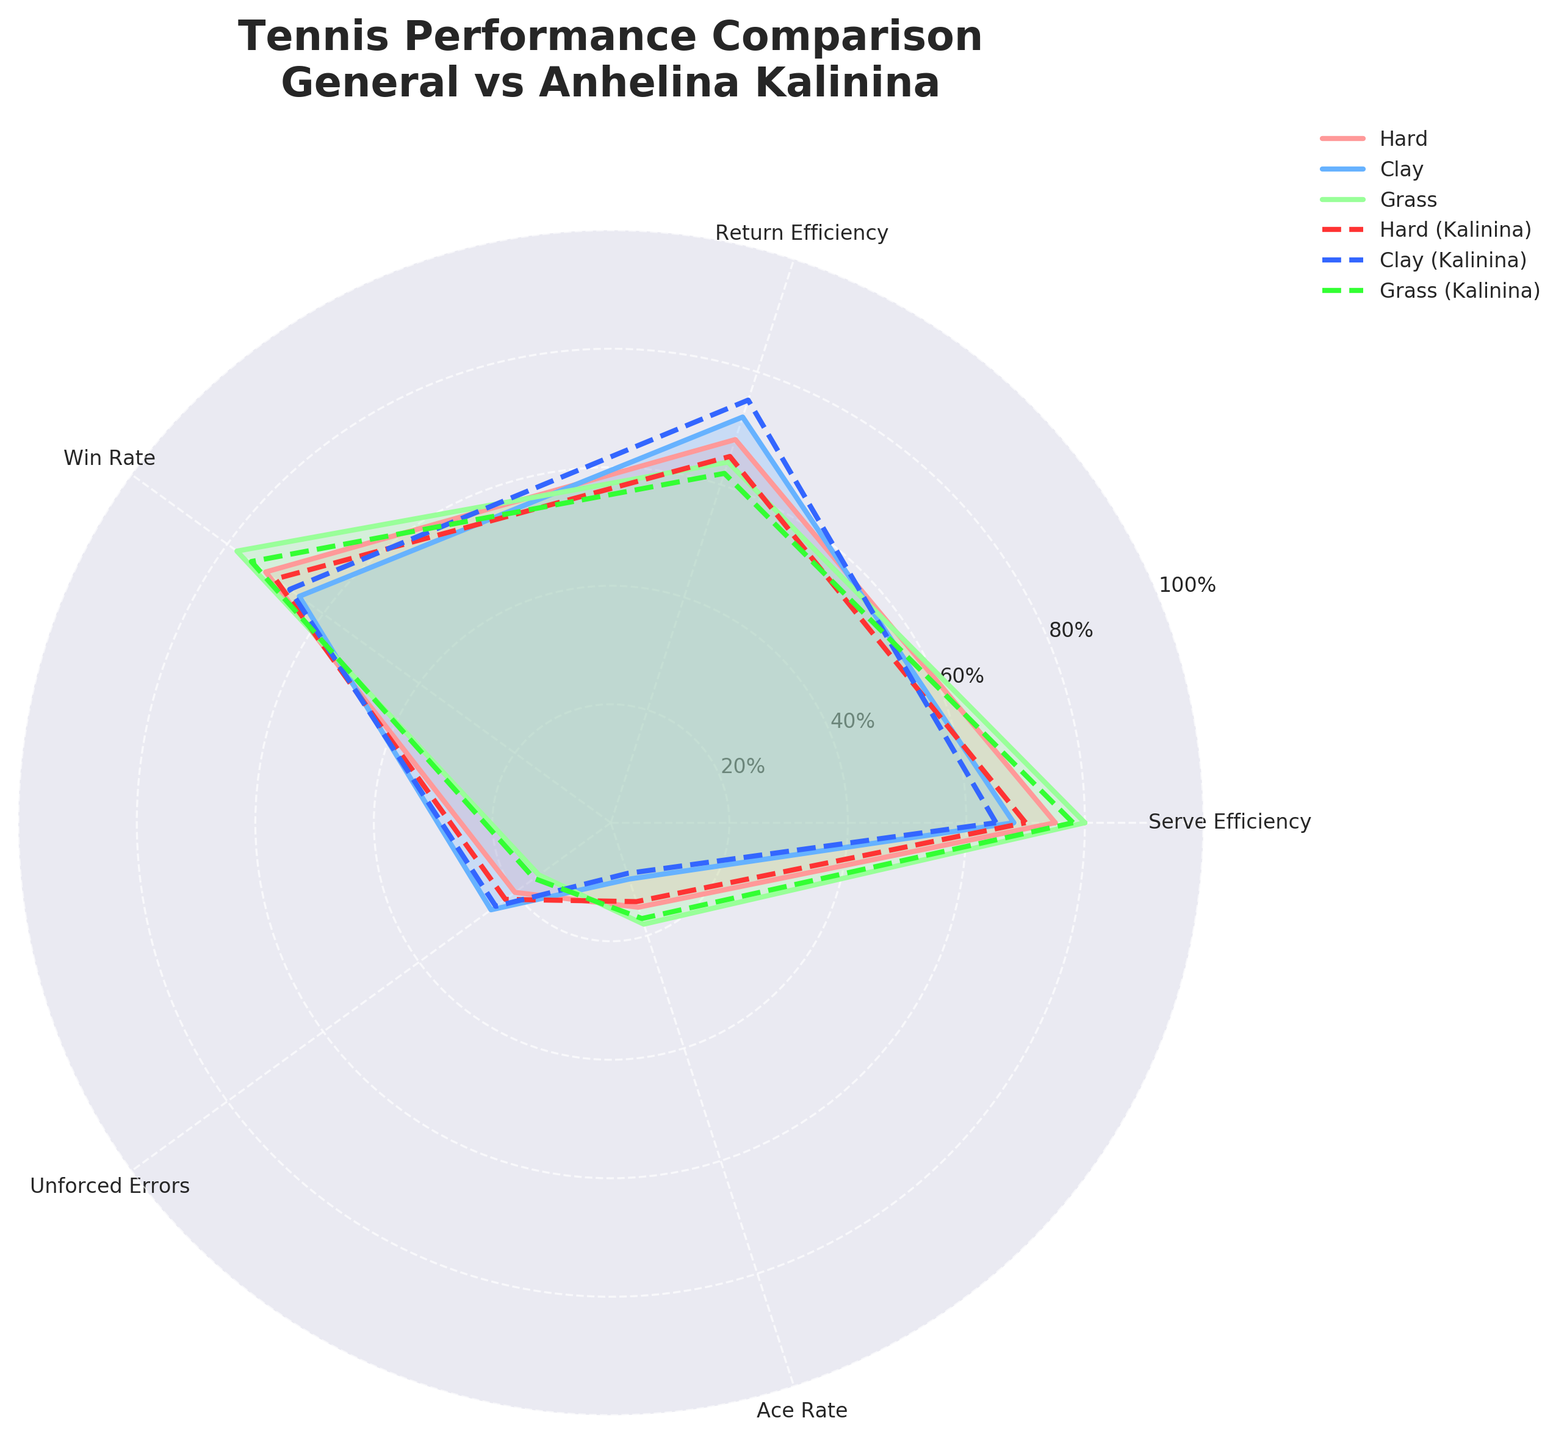What's the title of the figure? The title of the figure is indicated at the top and provides an overview of the data being presented.
Answer: Tennis Performance Comparison\nGeneral vs Anhelina Kalinina What surfaces are compared in the radar chart? The radar chart has separate lines representing different surfaces for both general players and Anhelina Kalinina.
Answer: Hard, Clay, Grass Which surface shows the highest Serve Efficiency for Anhelina Kalinina? By looking at the lines representing Anhelina Kalinina’s performance, we compare the Serve Efficiency values.
Answer: Grass How does Anhelina Kalinina's Ace Rate on Grass compare to the general player's Ace Rate on Grass? By observing the lines corresponding to Grass for both sets of data, we determine the Ace Rate for each.
Answer: Lower Which attribute has the largest difference in performance between general players and Anhelina Kalinina on Clay? We need to compare each attribute vertically between the general data and Anhelina Kalinina's data for Clay and find the one with the highest absolute difference.
Answer: Return Efficiency Between which surfaces does Anhelina Kalinina show the least variation in Win Rate? By comparing the Win Rate values of Anhelina Kalinina across all surfaces, we determine the surfaces with the closest values.
Answer: Hard and Clay What is the average Unforced Errors rate for Anhelina Kalinina across all surfaces? We sum the Unforced Errors rates for Anhelina Kalinina for each surface and divide by the number of surfaces (3).
Answer: (22 + 24 + 16) / 3 = 20.67 Which surface corresponds to the highest Win Rate for general players? By comparing the Win Rate values for each surface for general players, we identify the highest value.
Answer: Grass For general players, which surface has the lowest Return Efficiency? By checking the Return Efficiency values for general players, we find the smallest one.
Answer: Grass How does the Serve Efficiency on Hard surfaces for general players compare to Anhelina Kalinina? We look at the Serve Efficiency data for both general players and Anhelina Kalinina on Hard surfaces and compare the values.
Answer: Higher for general players 